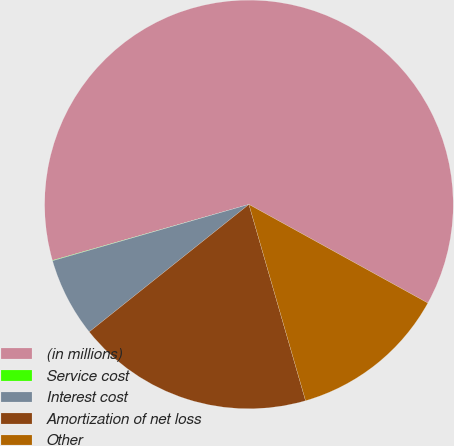<chart> <loc_0><loc_0><loc_500><loc_500><pie_chart><fcel>(in millions)<fcel>Service cost<fcel>Interest cost<fcel>Amortization of net loss<fcel>Other<nl><fcel>62.43%<fcel>0.03%<fcel>6.27%<fcel>18.75%<fcel>12.51%<nl></chart> 